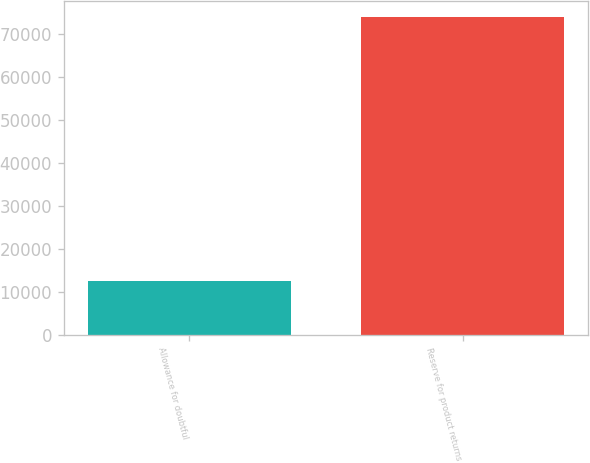<chart> <loc_0><loc_0><loc_500><loc_500><bar_chart><fcel>Allowance for doubtful<fcel>Reserve for product returns<nl><fcel>12420<fcel>73955<nl></chart> 